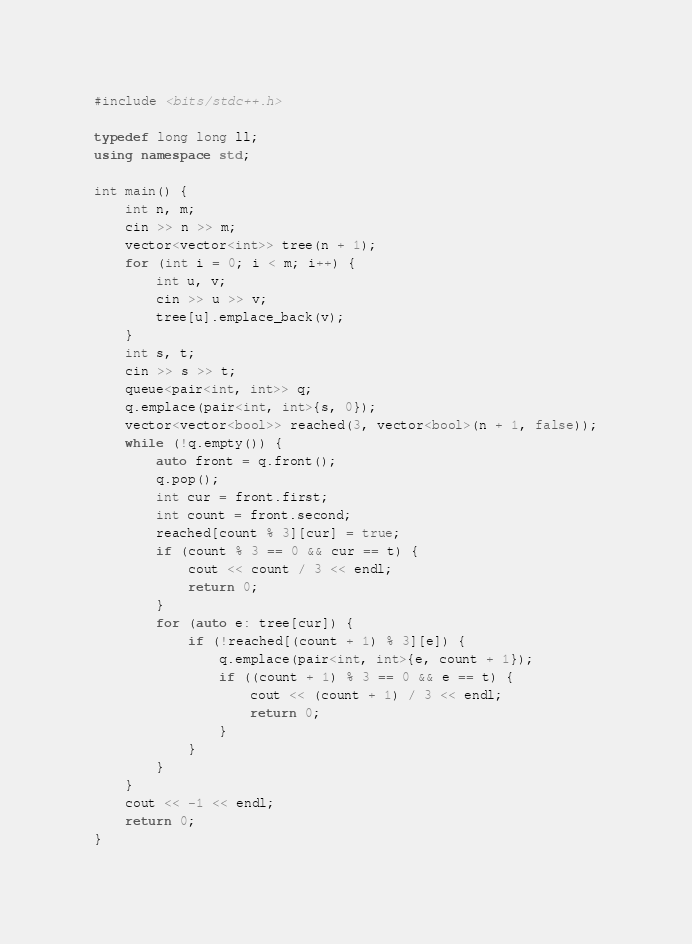Convert code to text. <code><loc_0><loc_0><loc_500><loc_500><_C++_>#include <bits/stdc++.h>

typedef long long ll;
using namespace std;

int main() {
    int n, m;
    cin >> n >> m;
    vector<vector<int>> tree(n + 1);
    for (int i = 0; i < m; i++) {
        int u, v;
        cin >> u >> v;
        tree[u].emplace_back(v);
    }
    int s, t;
    cin >> s >> t;
    queue<pair<int, int>> q;
    q.emplace(pair<int, int>{s, 0});
    vector<vector<bool>> reached(3, vector<bool>(n + 1, false));
    while (!q.empty()) {
        auto front = q.front();
        q.pop();
        int cur = front.first;
        int count = front.second;
        reached[count % 3][cur] = true;
        if (count % 3 == 0 && cur == t) {
            cout << count / 3 << endl;
            return 0;
        }
        for (auto e: tree[cur]) {
            if (!reached[(count + 1) % 3][e]) {
                q.emplace(pair<int, int>{e, count + 1});
                if ((count + 1) % 3 == 0 && e == t) {
                    cout << (count + 1) / 3 << endl;
                    return 0;
                }
            }
        }
    }
    cout << -1 << endl;
    return 0;
}
</code> 